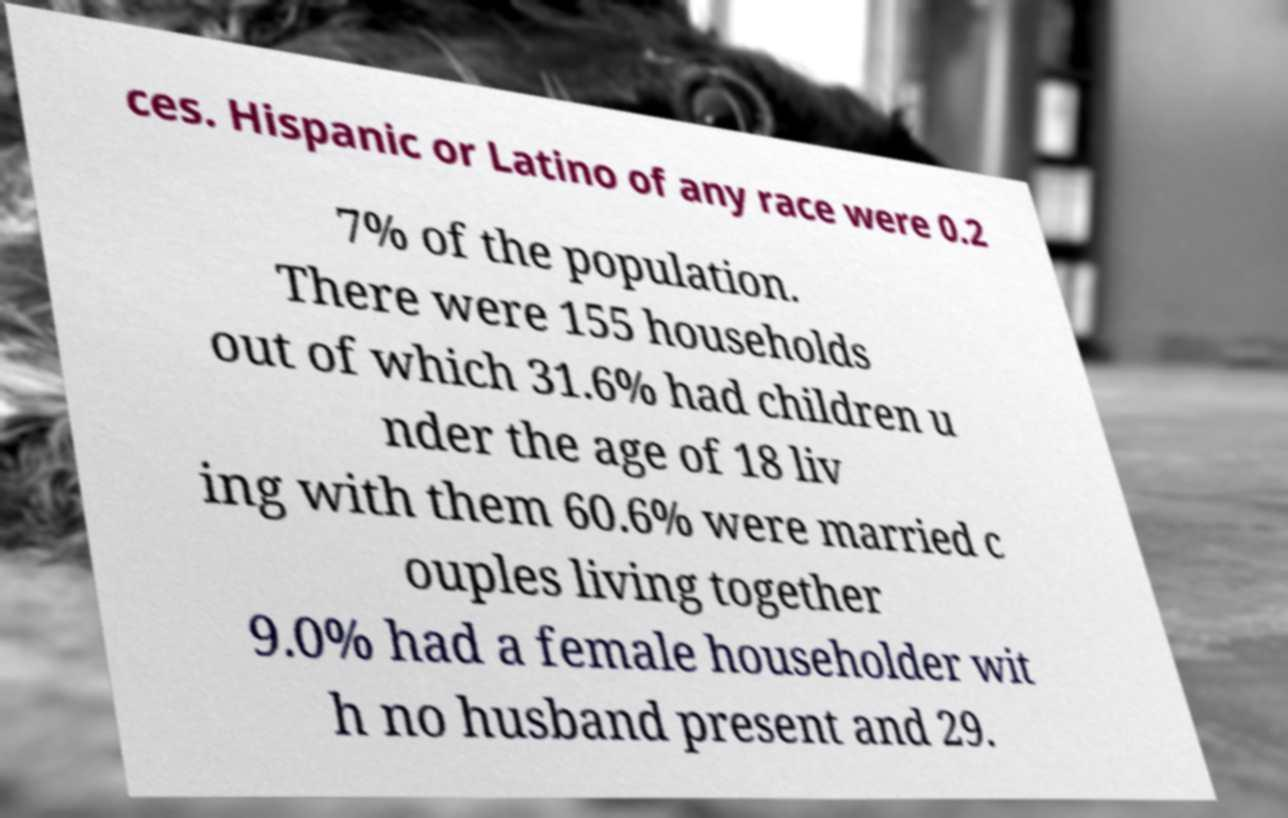What messages or text are displayed in this image? I need them in a readable, typed format. ces. Hispanic or Latino of any race were 0.2 7% of the population. There were 155 households out of which 31.6% had children u nder the age of 18 liv ing with them 60.6% were married c ouples living together 9.0% had a female householder wit h no husband present and 29. 